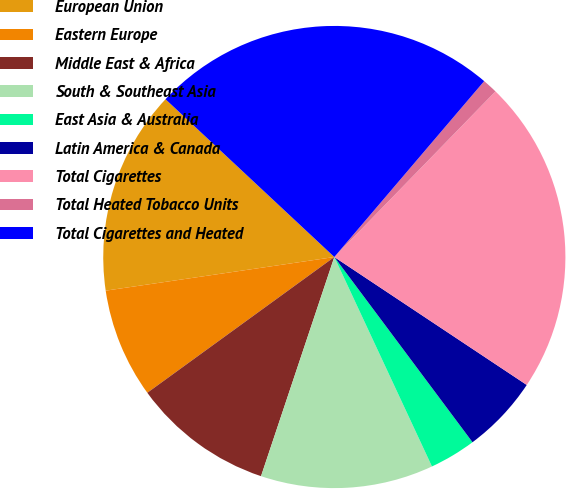Convert chart. <chart><loc_0><loc_0><loc_500><loc_500><pie_chart><fcel>European Union<fcel>Eastern Europe<fcel>Middle East & Africa<fcel>South & Southeast Asia<fcel>East Asia & Australia<fcel>Latin America & Canada<fcel>Total Cigarettes<fcel>Total Heated Tobacco Units<fcel>Total Cigarettes and Heated<nl><fcel>14.29%<fcel>7.67%<fcel>9.87%<fcel>12.08%<fcel>3.26%<fcel>5.46%<fcel>22.06%<fcel>1.05%<fcel>24.27%<nl></chart> 